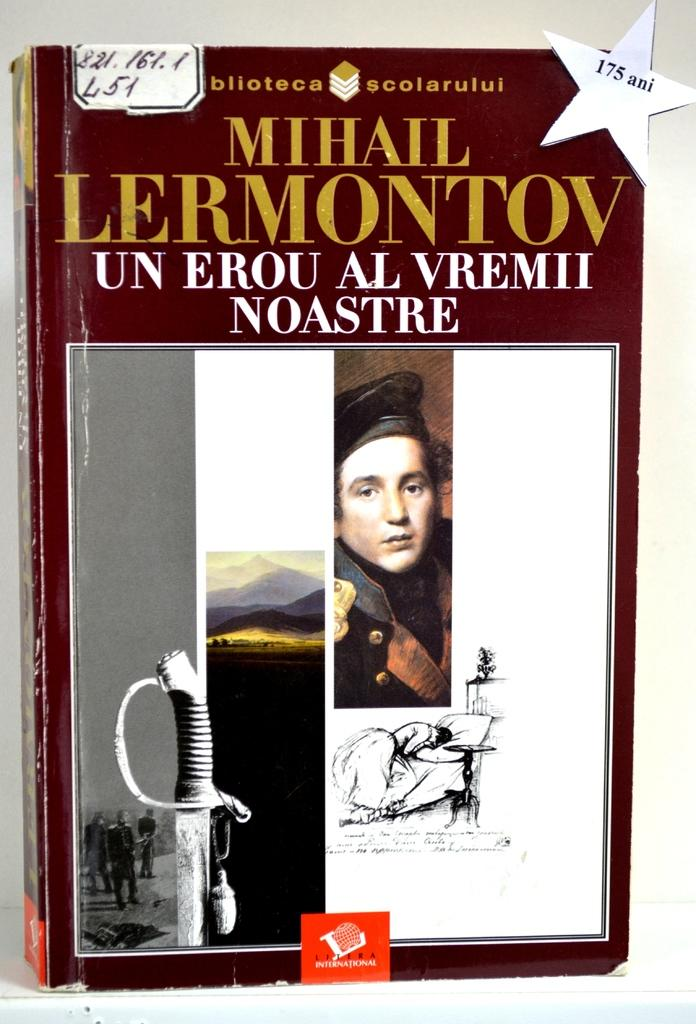Provide a one-sentence caption for the provided image. Book titled "Un Erou Al Vremii Noastre" showing a sword and a man's face on the cover. 